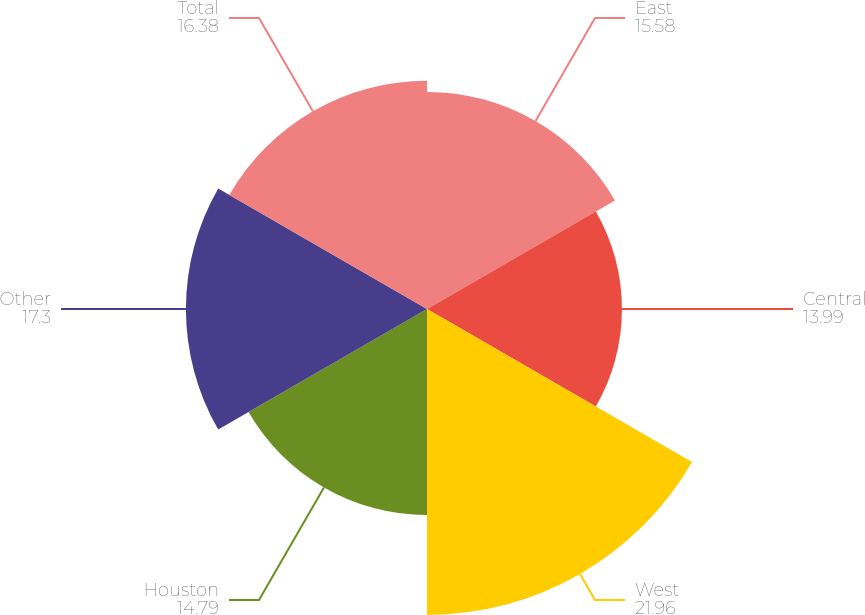Convert chart. <chart><loc_0><loc_0><loc_500><loc_500><pie_chart><fcel>East<fcel>Central<fcel>West<fcel>Houston<fcel>Other<fcel>Total<nl><fcel>15.58%<fcel>13.99%<fcel>21.96%<fcel>14.79%<fcel>17.3%<fcel>16.38%<nl></chart> 